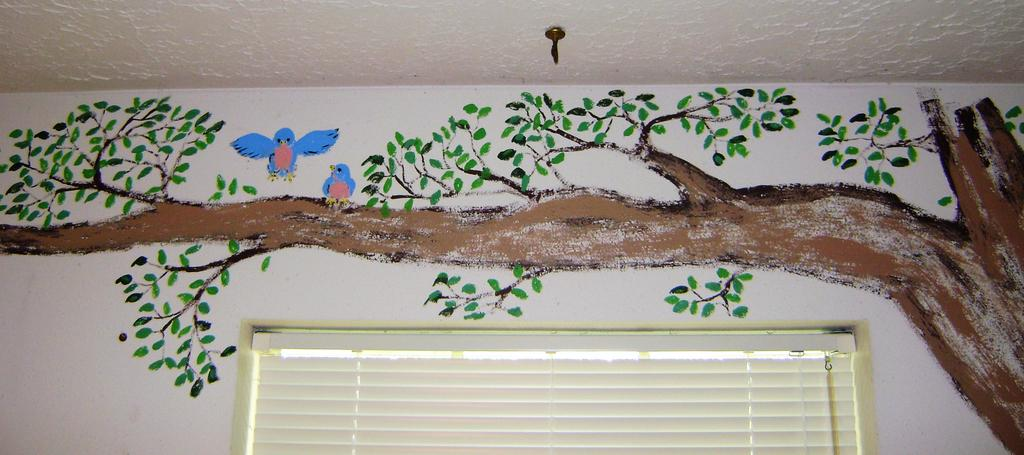What is the main color of the wall in the image? There is a white wall in the image. What is depicted on the wall? There is a drawing of a tree branch and drawings of two blue birds on the wall. Can you describe any other elements in the image related to the wall? There is a window blind visible in the image. How many potatoes are present in the image? There are no potatoes present in the image. What type of nation is depicted in the image? The image does not depict any nation; it features a white wall with drawings of a tree branch and two blue birds. 